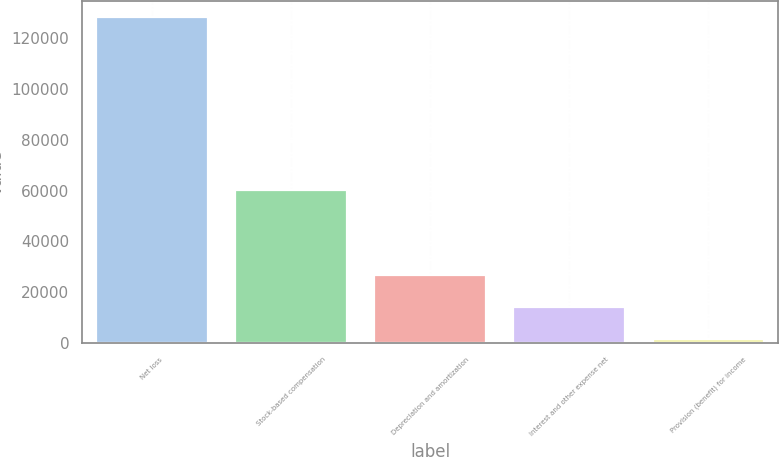Convert chart. <chart><loc_0><loc_0><loc_500><loc_500><bar_chart><fcel>Net loss<fcel>Stock-based compensation<fcel>Depreciation and amortization<fcel>Interest and other expense net<fcel>Provision (benefit) for income<nl><fcel>128302<fcel>60384<fcel>26815.6<fcel>14129.8<fcel>1444<nl></chart> 